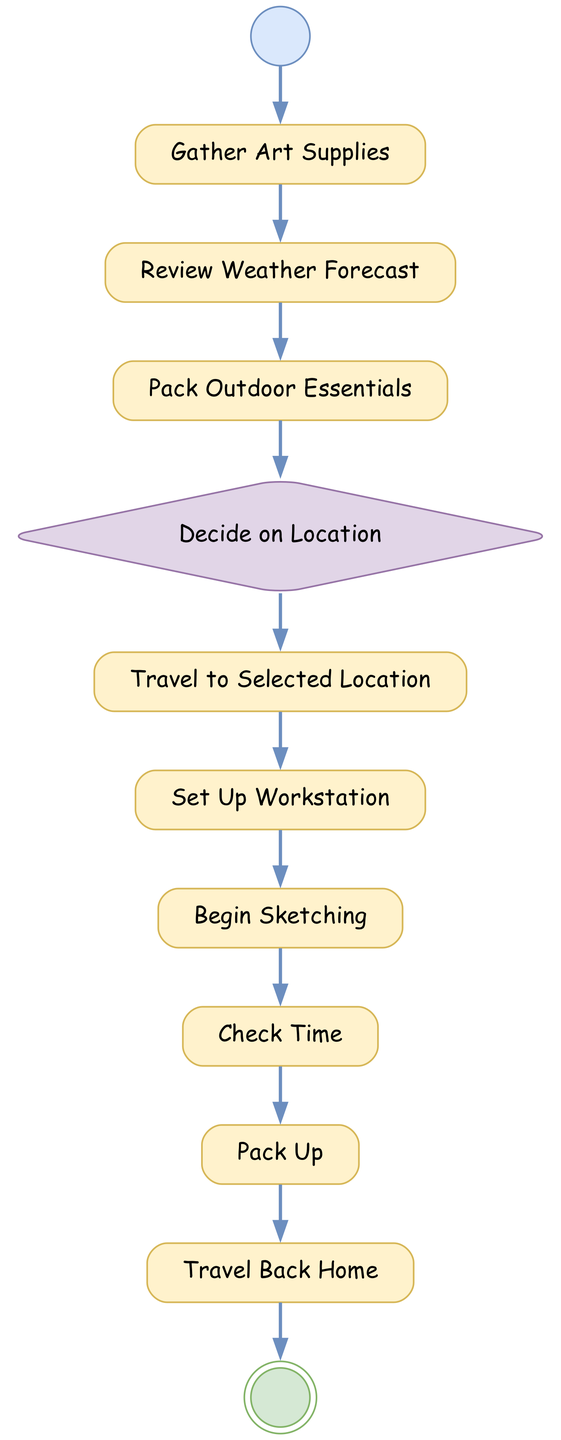What is the first activity in the diagram? The first activity type in the diagram is marked as "initial," which indicates the starting point. Following the diagram, the first named activity is "Start Day."
Answer: Start Day What activity follows "Gather Art Supplies"? The activity that comes immediately after "Gather Art Supplies" in the sequence is "Review Weather Forecast." This relationship can be observed directly in the flow of the diagram.
Answer: Review Weather Forecast How many decision nodes are in the diagram? In the provided data, there is only one decision node, specifically "Decide on Location." This is determined by counting the nodes with the type "decision" in the diagram.
Answer: One What is the final activity in the diagram? The final activity is marked with the type "final." Based on the diagram and its flow, the last activity is "End Day."
Answer: End Day What activity must be completed before traveling to the selected location? According to the sequence of activities, the action that must be completed prior to "Travel to Selected Location" is "Decide on Location." This decision step is essential to determine the place for sketching.
Answer: Decide on Location What activity follows "Check Time"? The next activity after "Check Time" is "Pack Up." This can be directly derived by looking at the flow from "Check Time" in the diagram.
Answer: Pack Up How many total activities are represented in the diagram? The total number of activities in the diagram includes all types except for the initial and final nodes. Counting the other activities gives a total of eleven.
Answer: Eleven If someone skips the "Review Weather Forecast" step, what activity would they proceed to? If the "Review Weather Forecast" step is skipped, the next activity in the flow would be "Pack Outdoor Essentials." This demonstrates the flow continuity despite the skipped step.
Answer: Pack Outdoor Essentials What is the result of completing the last activity? Upon completing the last activity, which is "End Day," it signifies the conclusion of the day's sketching activities, marking the end point in the diagram.
Answer: End Day 